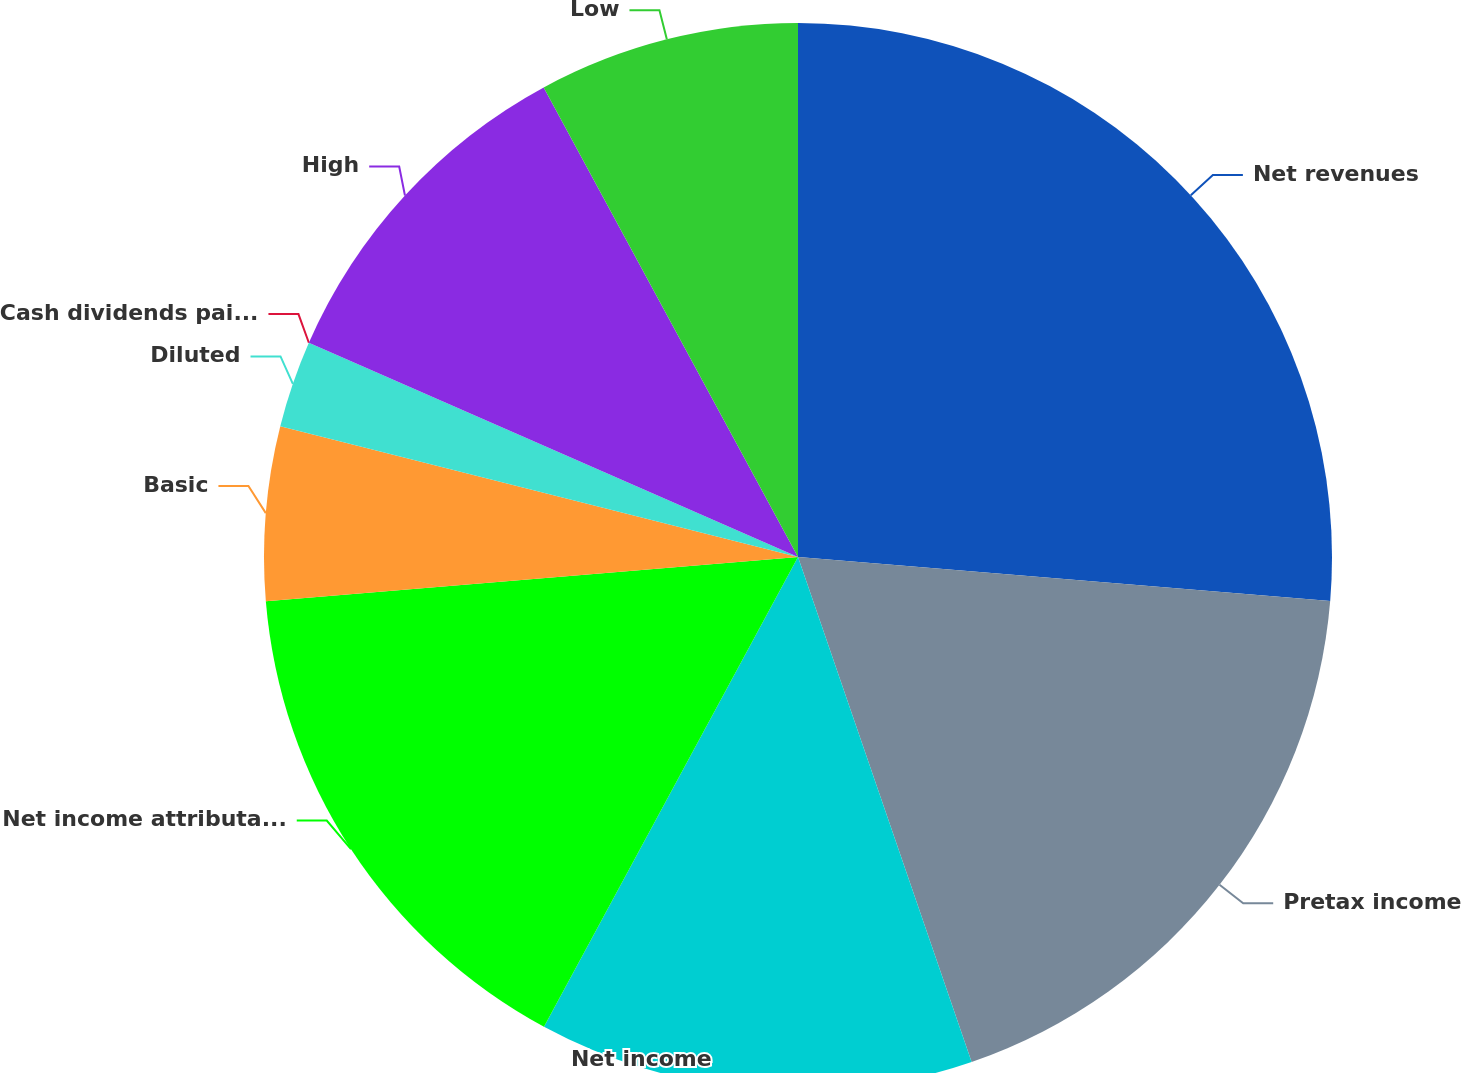Convert chart. <chart><loc_0><loc_0><loc_500><loc_500><pie_chart><fcel>Net revenues<fcel>Pretax income<fcel>Net income<fcel>Net income attributable to<fcel>Basic<fcel>Diluted<fcel>Cash dividends paid per common<fcel>High<fcel>Low<nl><fcel>26.31%<fcel>18.42%<fcel>13.16%<fcel>15.79%<fcel>5.26%<fcel>2.63%<fcel>0.0%<fcel>10.53%<fcel>7.9%<nl></chart> 